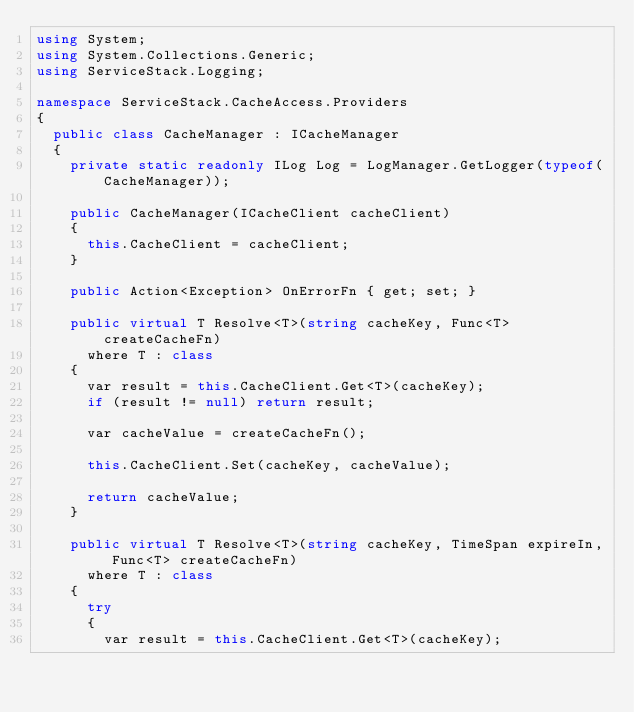Convert code to text. <code><loc_0><loc_0><loc_500><loc_500><_C#_>using System;
using System.Collections.Generic;
using ServiceStack.Logging;

namespace ServiceStack.CacheAccess.Providers
{
	public class CacheManager : ICacheManager
	{
		private static readonly ILog Log = LogManager.GetLogger(typeof(CacheManager));

		public CacheManager(ICacheClient cacheClient)
		{
			this.CacheClient = cacheClient;
		}

		public Action<Exception> OnErrorFn { get; set; }

		public virtual T Resolve<T>(string cacheKey, Func<T> createCacheFn)
			where T : class
		{
			var result = this.CacheClient.Get<T>(cacheKey);
			if (result != null) return result;

			var cacheValue = createCacheFn();

			this.CacheClient.Set(cacheKey, cacheValue);

			return cacheValue;
		}

		public virtual T Resolve<T>(string cacheKey, TimeSpan expireIn, Func<T> createCacheFn)
			where T : class
		{
			try
			{
				var result = this.CacheClient.Get<T>(cacheKey);</code> 